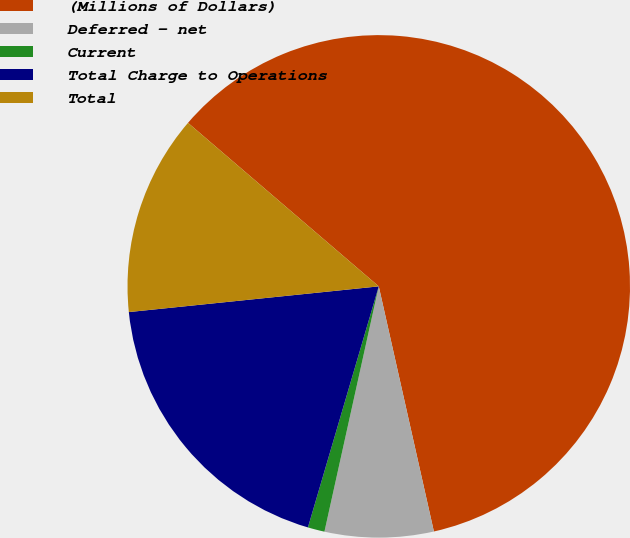Convert chart to OTSL. <chart><loc_0><loc_0><loc_500><loc_500><pie_chart><fcel>(Millions of Dollars)<fcel>Deferred - net<fcel>Current<fcel>Total Charge to Operations<fcel>Total<nl><fcel>60.2%<fcel>6.99%<fcel>1.08%<fcel>18.82%<fcel>12.91%<nl></chart> 